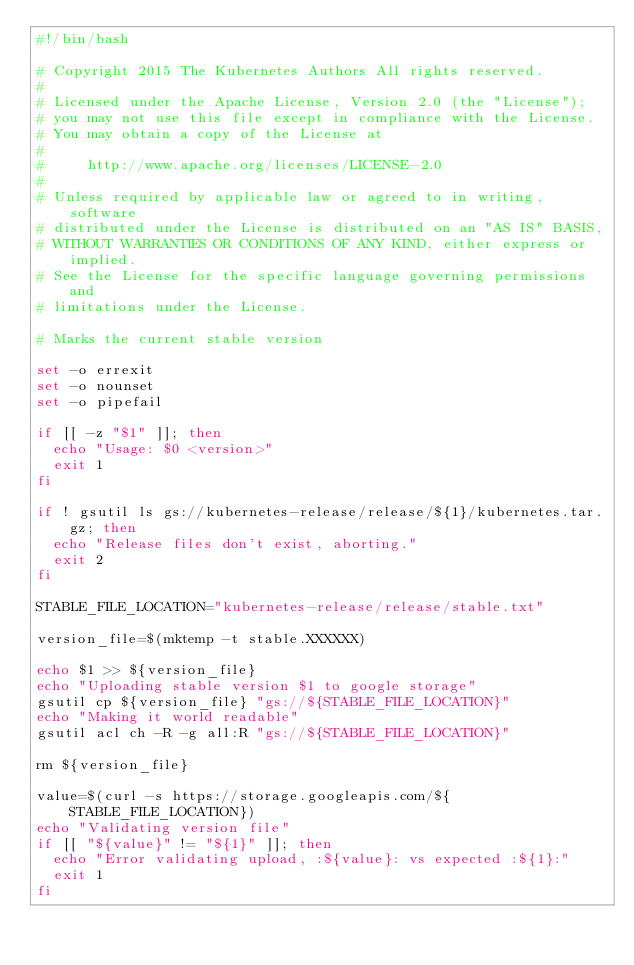Convert code to text. <code><loc_0><loc_0><loc_500><loc_500><_Bash_>#!/bin/bash

# Copyright 2015 The Kubernetes Authors All rights reserved.
#
# Licensed under the Apache License, Version 2.0 (the "License");
# you may not use this file except in compliance with the License.
# You may obtain a copy of the License at
#
#     http://www.apache.org/licenses/LICENSE-2.0
#
# Unless required by applicable law or agreed to in writing, software
# distributed under the License is distributed on an "AS IS" BASIS,
# WITHOUT WARRANTIES OR CONDITIONS OF ANY KIND, either express or implied.
# See the License for the specific language governing permissions and
# limitations under the License.

# Marks the current stable version

set -o errexit
set -o nounset
set -o pipefail

if [[ -z "$1" ]]; then
  echo "Usage: $0 <version>"
  exit 1
fi

if ! gsutil ls gs://kubernetes-release/release/${1}/kubernetes.tar.gz; then
  echo "Release files don't exist, aborting."
  exit 2
fi

STABLE_FILE_LOCATION="kubernetes-release/release/stable.txt"

version_file=$(mktemp -t stable.XXXXXX)

echo $1 >> ${version_file}
echo "Uploading stable version $1 to google storage"
gsutil cp ${version_file} "gs://${STABLE_FILE_LOCATION}"
echo "Making it world readable"
gsutil acl ch -R -g all:R "gs://${STABLE_FILE_LOCATION}"

rm ${version_file}

value=$(curl -s https://storage.googleapis.com/${STABLE_FILE_LOCATION})
echo "Validating version file"
if [[ "${value}" != "${1}" ]]; then
  echo "Error validating upload, :${value}: vs expected :${1}:"
  exit 1
fi
</code> 